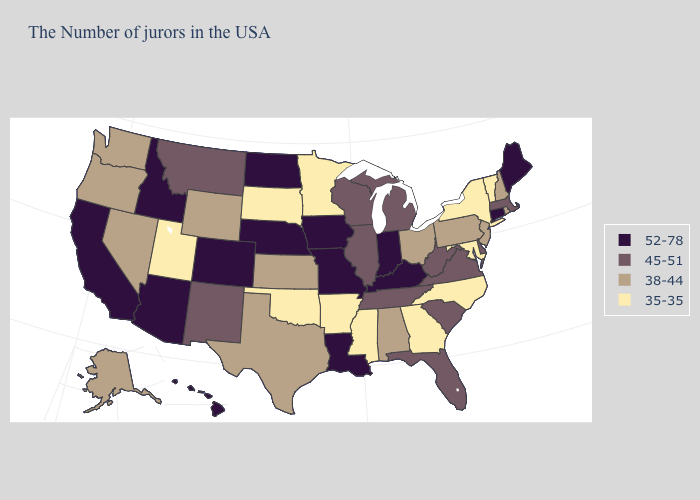Among the states that border Tennessee , does Virginia have the highest value?
Short answer required. No. Name the states that have a value in the range 35-35?
Write a very short answer. Vermont, New York, Maryland, North Carolina, Georgia, Mississippi, Arkansas, Minnesota, Oklahoma, South Dakota, Utah. Name the states that have a value in the range 45-51?
Answer briefly. Massachusetts, Delaware, Virginia, South Carolina, West Virginia, Florida, Michigan, Tennessee, Wisconsin, Illinois, New Mexico, Montana. Does Nevada have the lowest value in the West?
Write a very short answer. No. Does Rhode Island have the lowest value in the Northeast?
Write a very short answer. No. What is the value of Maryland?
Keep it brief. 35-35. What is the lowest value in the USA?
Write a very short answer. 35-35. Which states have the highest value in the USA?
Short answer required. Maine, Connecticut, Kentucky, Indiana, Louisiana, Missouri, Iowa, Nebraska, North Dakota, Colorado, Arizona, Idaho, California, Hawaii. Does Alabama have a lower value than Mississippi?
Quick response, please. No. Among the states that border New Mexico , does Utah have the lowest value?
Give a very brief answer. Yes. Name the states that have a value in the range 45-51?
Quick response, please. Massachusetts, Delaware, Virginia, South Carolina, West Virginia, Florida, Michigan, Tennessee, Wisconsin, Illinois, New Mexico, Montana. Is the legend a continuous bar?
Be succinct. No. Does Louisiana have the same value as Arkansas?
Quick response, please. No. Does Virginia have the lowest value in the USA?
Short answer required. No. Does Montana have the highest value in the West?
Answer briefly. No. 